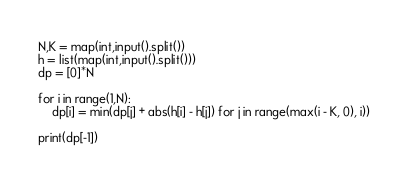<code> <loc_0><loc_0><loc_500><loc_500><_Python_>N,K = map(int,input().split())
h = list(map(int,input().split()))
dp = [0]*N

for i in range(1,N):
    dp[i] = min(dp[j] + abs(h[i] - h[j]) for j in range(max(i - K, 0), i))

print(dp[-1])
</code> 